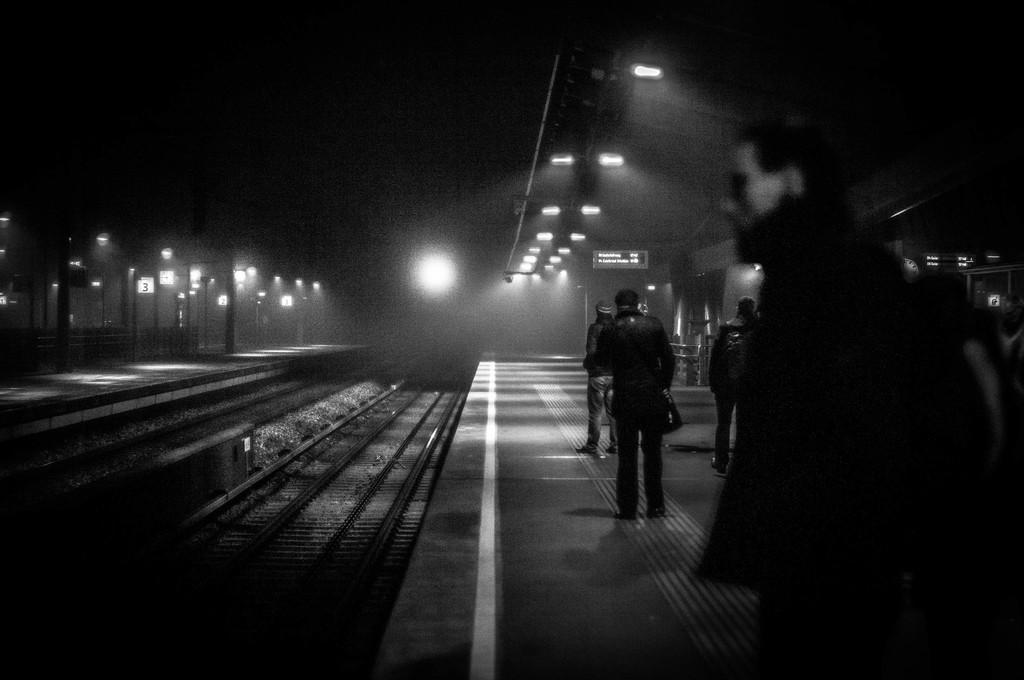Please provide a concise description of this image. In this image I can see few persons standing. I can also see few tracks, background I can see few lights. 